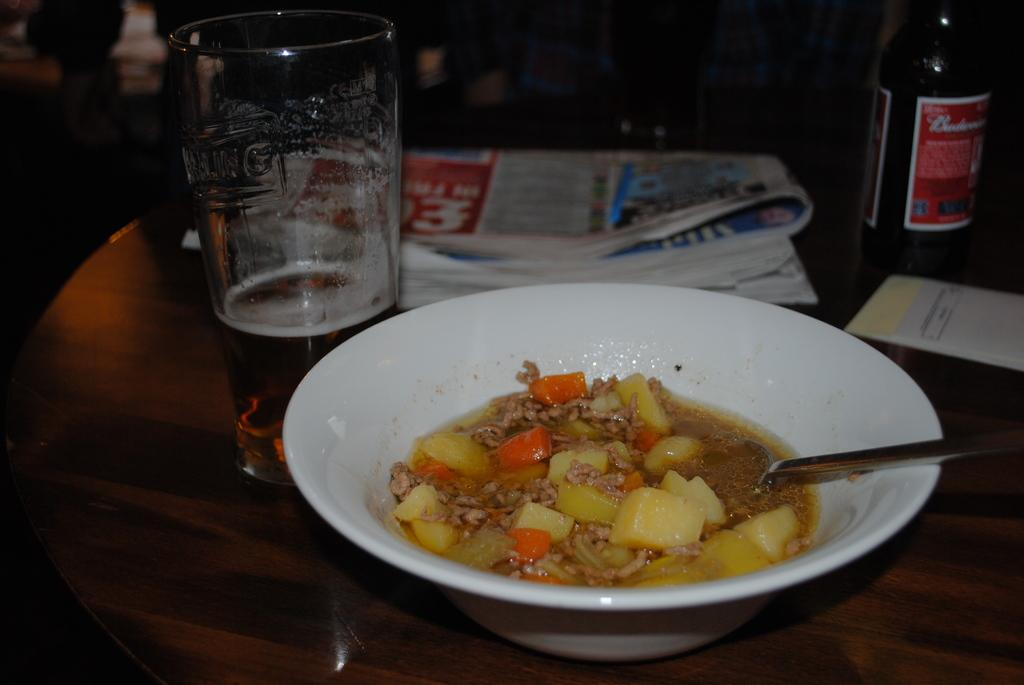What piece of furniture is present in the image? There is a table in the image. What is on the table? There is a food item in a bowl on the table, and there is a spoon in the bowl. What else can be seen in the image besides the table and bowl? There is a newspaper, a bottle, a glass, and a cover in the image. Can you describe the background of the image? The background of the image is blurred. Can you tell me how many cats are playing with a hook in the image? There are no cats or hooks present in the image. What type of bubble can be seen floating near the glass in the image? There are no bubbles present in the image. 